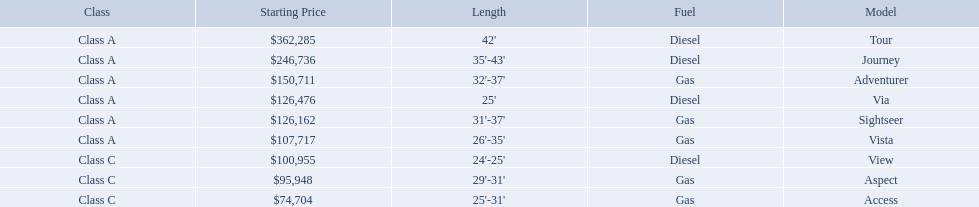What are the prices? $362,285, $246,736, $150,711, $126,476, $126,162, $107,717, $100,955, $95,948, $74,704. What is the top price? $362,285. What model has this price? Tour. 